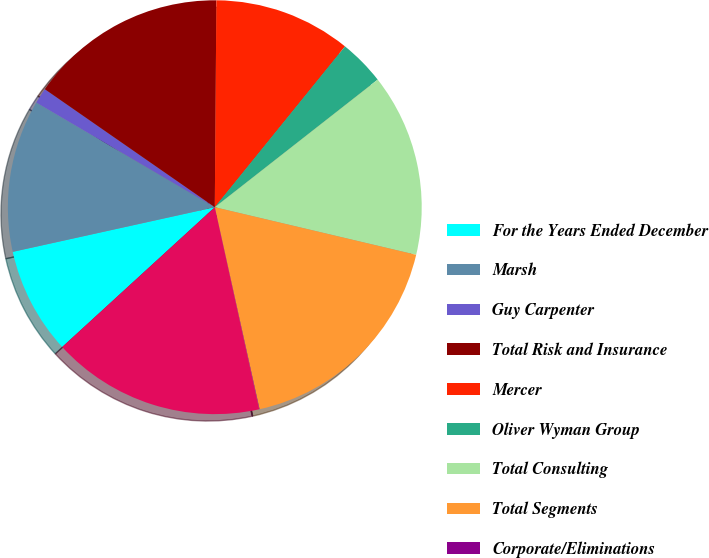Convert chart to OTSL. <chart><loc_0><loc_0><loc_500><loc_500><pie_chart><fcel>For the Years Ended December<fcel>Marsh<fcel>Guy Carpenter<fcel>Total Risk and Insurance<fcel>Mercer<fcel>Oliver Wyman Group<fcel>Total Consulting<fcel>Total Segments<fcel>Corporate/Eliminations<fcel>Total<nl><fcel>8.34%<fcel>11.9%<fcel>1.22%<fcel>15.46%<fcel>10.71%<fcel>3.59%<fcel>14.27%<fcel>17.83%<fcel>0.03%<fcel>16.64%<nl></chart> 